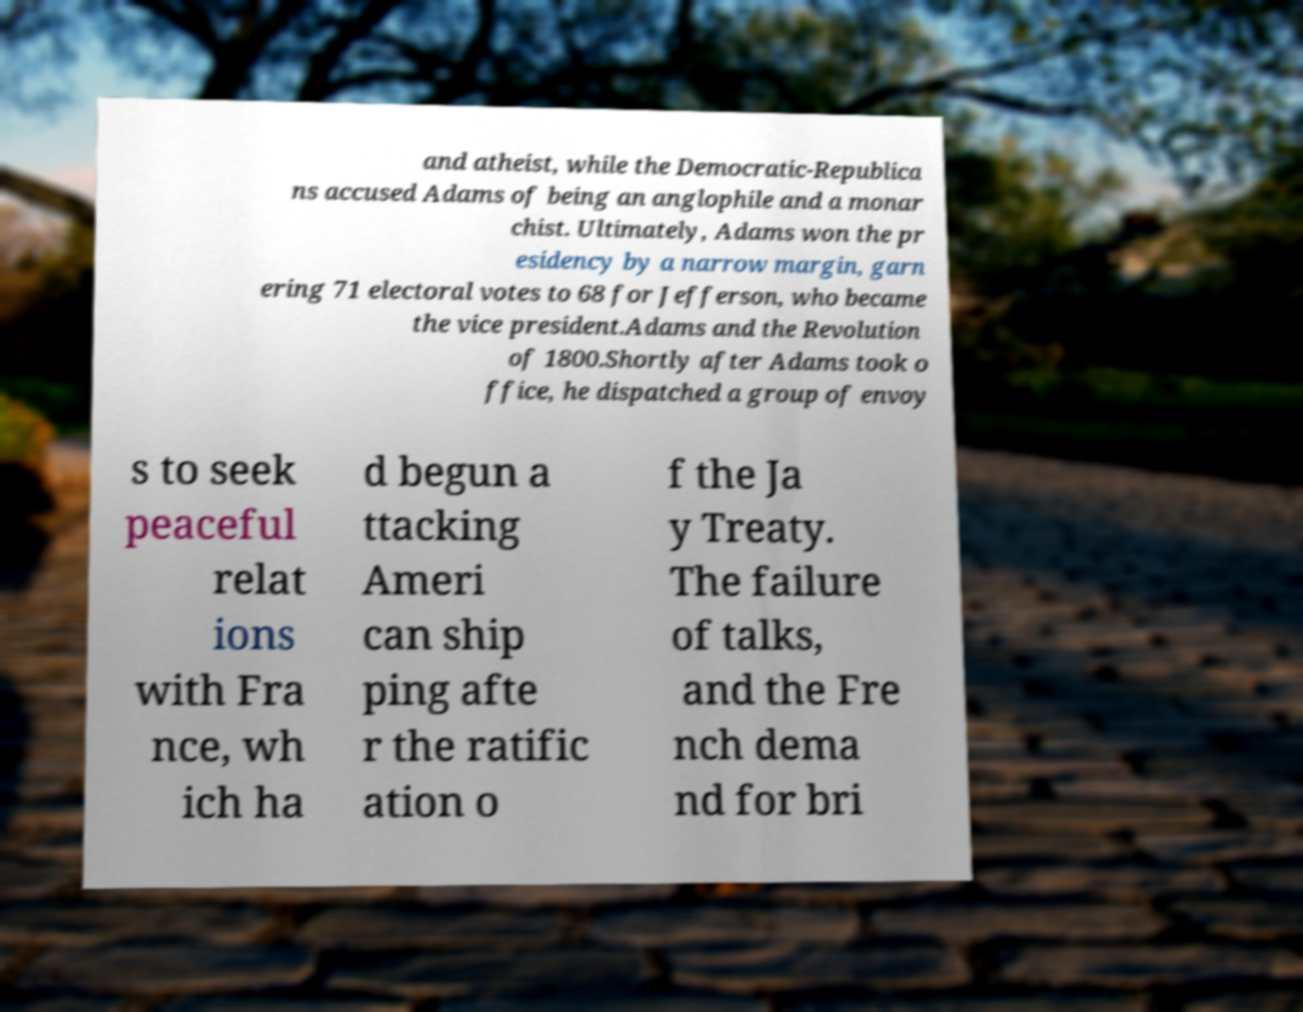Can you read and provide the text displayed in the image?This photo seems to have some interesting text. Can you extract and type it out for me? and atheist, while the Democratic-Republica ns accused Adams of being an anglophile and a monar chist. Ultimately, Adams won the pr esidency by a narrow margin, garn ering 71 electoral votes to 68 for Jefferson, who became the vice president.Adams and the Revolution of 1800.Shortly after Adams took o ffice, he dispatched a group of envoy s to seek peaceful relat ions with Fra nce, wh ich ha d begun a ttacking Ameri can ship ping afte r the ratific ation o f the Ja y Treaty. The failure of talks, and the Fre nch dema nd for bri 